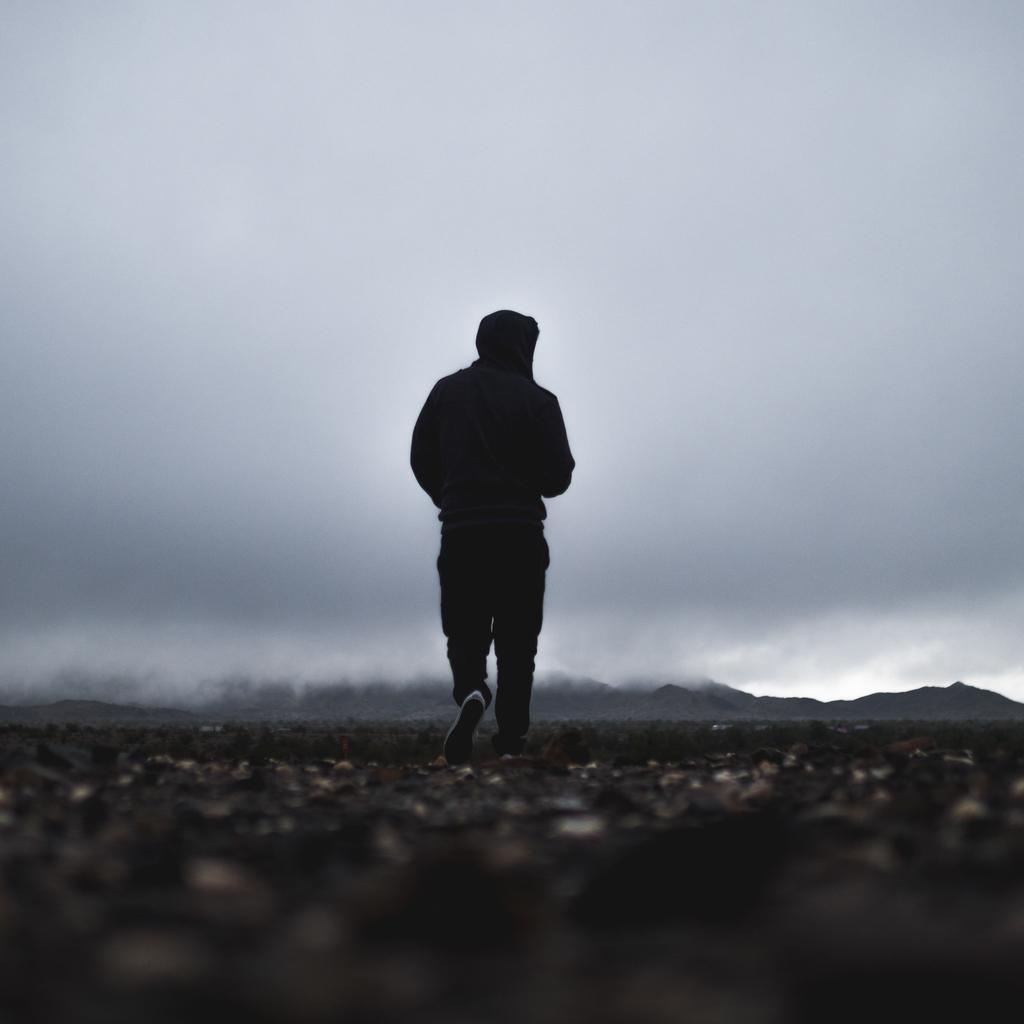Describe this image in one or two sentences. In this picture we can observe a person walking on the land. He is wearing black color hoodie. In the background there are hills and a sky with some clouds. 